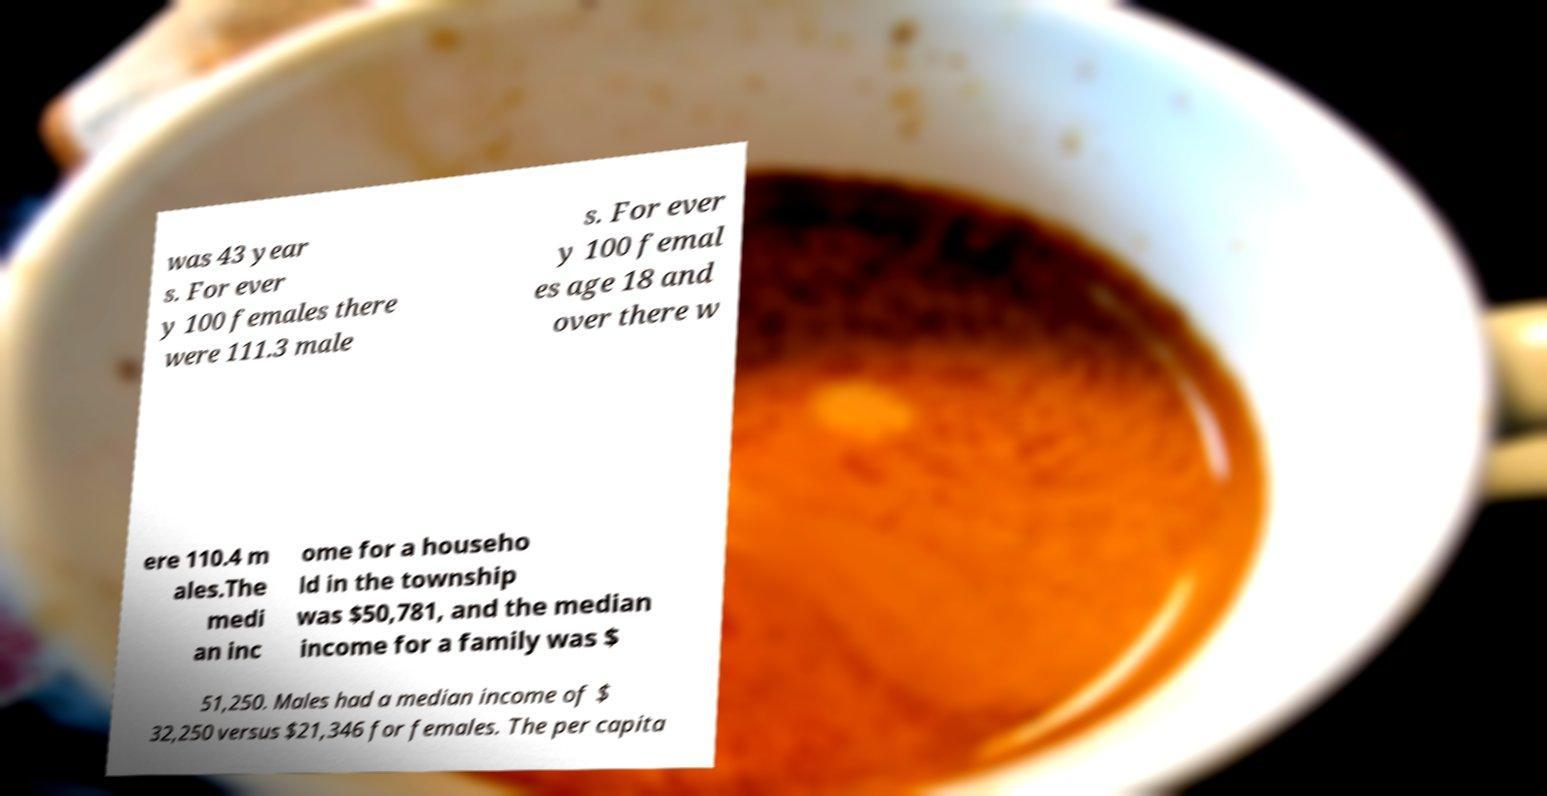Can you read and provide the text displayed in the image?This photo seems to have some interesting text. Can you extract and type it out for me? was 43 year s. For ever y 100 females there were 111.3 male s. For ever y 100 femal es age 18 and over there w ere 110.4 m ales.The medi an inc ome for a househo ld in the township was $50,781, and the median income for a family was $ 51,250. Males had a median income of $ 32,250 versus $21,346 for females. The per capita 